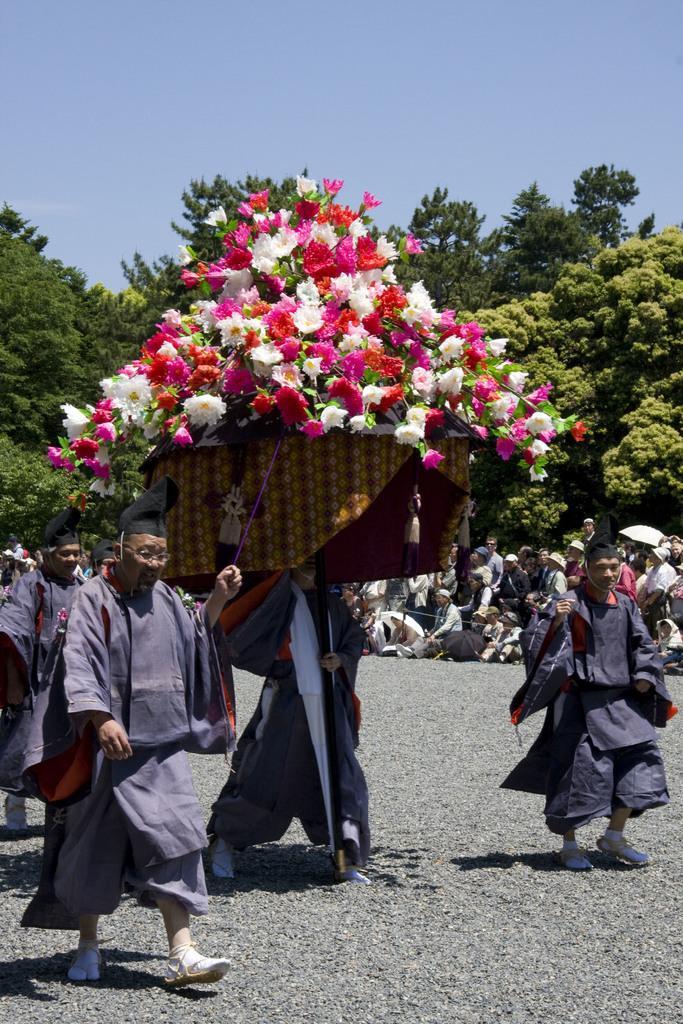Please provide a concise description of this image. In the center of the image we can see some people are walking on the road and two people are holding a box which contains flowers. In the background of the image we can see the trees and a group of people are sitting. At the top of the image we can see the sky. At the bottom of the image we can see the road. 